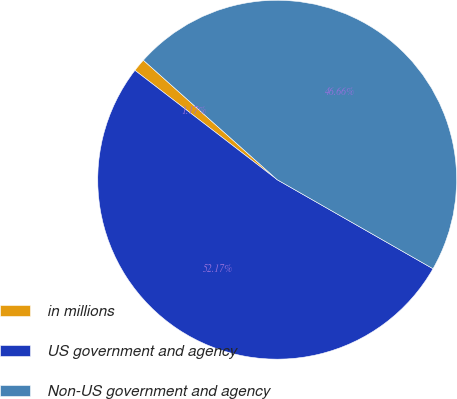Convert chart. <chart><loc_0><loc_0><loc_500><loc_500><pie_chart><fcel>in millions<fcel>US government and agency<fcel>Non-US government and agency<nl><fcel>1.17%<fcel>52.17%<fcel>46.66%<nl></chart> 